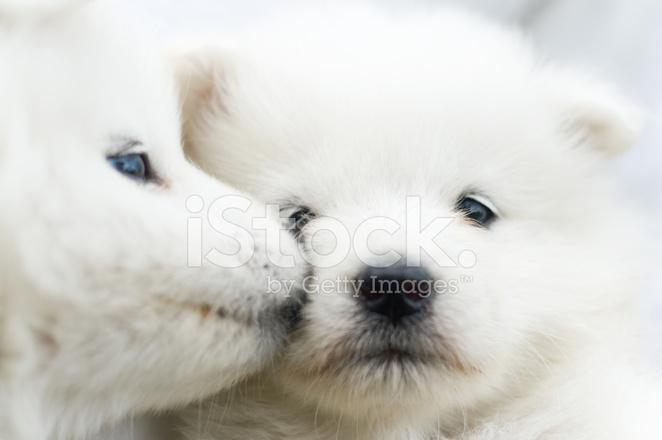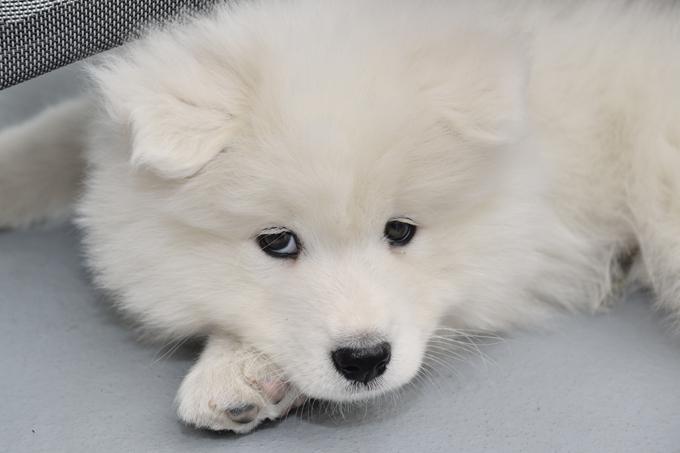The first image is the image on the left, the second image is the image on the right. Analyze the images presented: Is the assertion "The dog on the right has its mouth wide open." valid? Answer yes or no. No. The first image is the image on the left, the second image is the image on the right. Considering the images on both sides, is "Right image features a white dog with its mouth open and tongue showing." valid? Answer yes or no. No. 